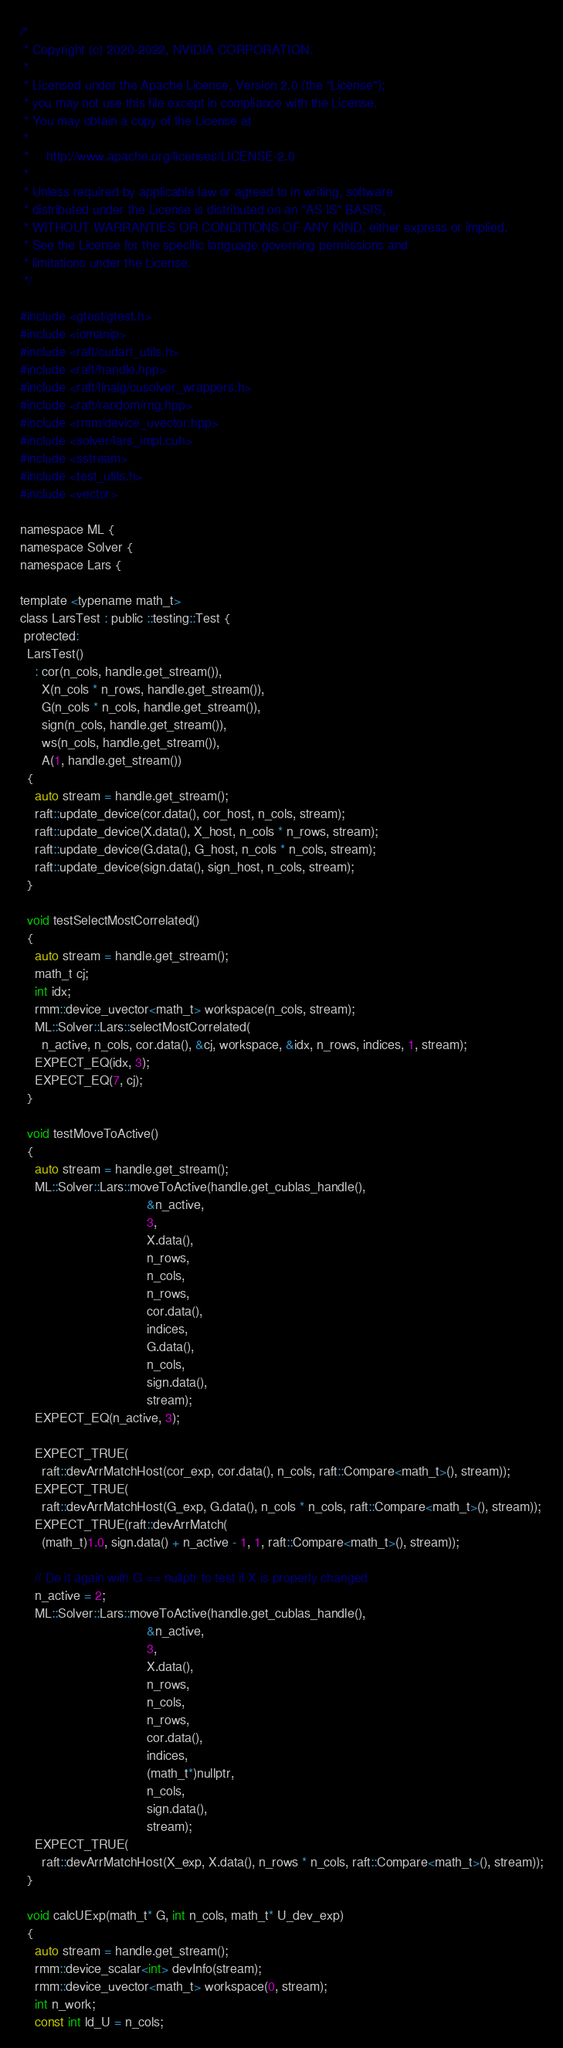<code> <loc_0><loc_0><loc_500><loc_500><_Cuda_>/*
 * Copyright (c) 2020-2022, NVIDIA CORPORATION.
 *
 * Licensed under the Apache License, Version 2.0 (the "License");
 * you may not use this file except in compliance with the License.
 * You may obtain a copy of the License at
 *
 *     http://www.apache.org/licenses/LICENSE-2.0
 *
 * Unless required by applicable law or agreed to in writing, software
 * distributed under the License is distributed on an "AS IS" BASIS,
 * WITHOUT WARRANTIES OR CONDITIONS OF ANY KIND, either express or implied.
 * See the License for the specific language governing permissions and
 * limitations under the License.
 */

#include <gtest/gtest.h>
#include <iomanip>
#include <raft/cudart_utils.h>
#include <raft/handle.hpp>
#include <raft/linalg/cusolver_wrappers.h>
#include <raft/random/rng.hpp>
#include <rmm/device_uvector.hpp>
#include <solver/lars_impl.cuh>
#include <sstream>
#include <test_utils.h>
#include <vector>

namespace ML {
namespace Solver {
namespace Lars {

template <typename math_t>
class LarsTest : public ::testing::Test {
 protected:
  LarsTest()
    : cor(n_cols, handle.get_stream()),
      X(n_cols * n_rows, handle.get_stream()),
      G(n_cols * n_cols, handle.get_stream()),
      sign(n_cols, handle.get_stream()),
      ws(n_cols, handle.get_stream()),
      A(1, handle.get_stream())
  {
    auto stream = handle.get_stream();
    raft::update_device(cor.data(), cor_host, n_cols, stream);
    raft::update_device(X.data(), X_host, n_cols * n_rows, stream);
    raft::update_device(G.data(), G_host, n_cols * n_cols, stream);
    raft::update_device(sign.data(), sign_host, n_cols, stream);
  }

  void testSelectMostCorrelated()
  {
    auto stream = handle.get_stream();
    math_t cj;
    int idx;
    rmm::device_uvector<math_t> workspace(n_cols, stream);
    ML::Solver::Lars::selectMostCorrelated(
      n_active, n_cols, cor.data(), &cj, workspace, &idx, n_rows, indices, 1, stream);
    EXPECT_EQ(idx, 3);
    EXPECT_EQ(7, cj);
  }

  void testMoveToActive()
  {
    auto stream = handle.get_stream();
    ML::Solver::Lars::moveToActive(handle.get_cublas_handle(),
                                   &n_active,
                                   3,
                                   X.data(),
                                   n_rows,
                                   n_cols,
                                   n_rows,
                                   cor.data(),
                                   indices,
                                   G.data(),
                                   n_cols,
                                   sign.data(),
                                   stream);
    EXPECT_EQ(n_active, 3);

    EXPECT_TRUE(
      raft::devArrMatchHost(cor_exp, cor.data(), n_cols, raft::Compare<math_t>(), stream));
    EXPECT_TRUE(
      raft::devArrMatchHost(G_exp, G.data(), n_cols * n_cols, raft::Compare<math_t>(), stream));
    EXPECT_TRUE(raft::devArrMatch(
      (math_t)1.0, sign.data() + n_active - 1, 1, raft::Compare<math_t>(), stream));

    // Do it again with G == nullptr to test if X is properly changed
    n_active = 2;
    ML::Solver::Lars::moveToActive(handle.get_cublas_handle(),
                                   &n_active,
                                   3,
                                   X.data(),
                                   n_rows,
                                   n_cols,
                                   n_rows,
                                   cor.data(),
                                   indices,
                                   (math_t*)nullptr,
                                   n_cols,
                                   sign.data(),
                                   stream);
    EXPECT_TRUE(
      raft::devArrMatchHost(X_exp, X.data(), n_rows * n_cols, raft::Compare<math_t>(), stream));
  }

  void calcUExp(math_t* G, int n_cols, math_t* U_dev_exp)
  {
    auto stream = handle.get_stream();
    rmm::device_scalar<int> devInfo(stream);
    rmm::device_uvector<math_t> workspace(0, stream);
    int n_work;
    const int ld_U = n_cols;</code> 